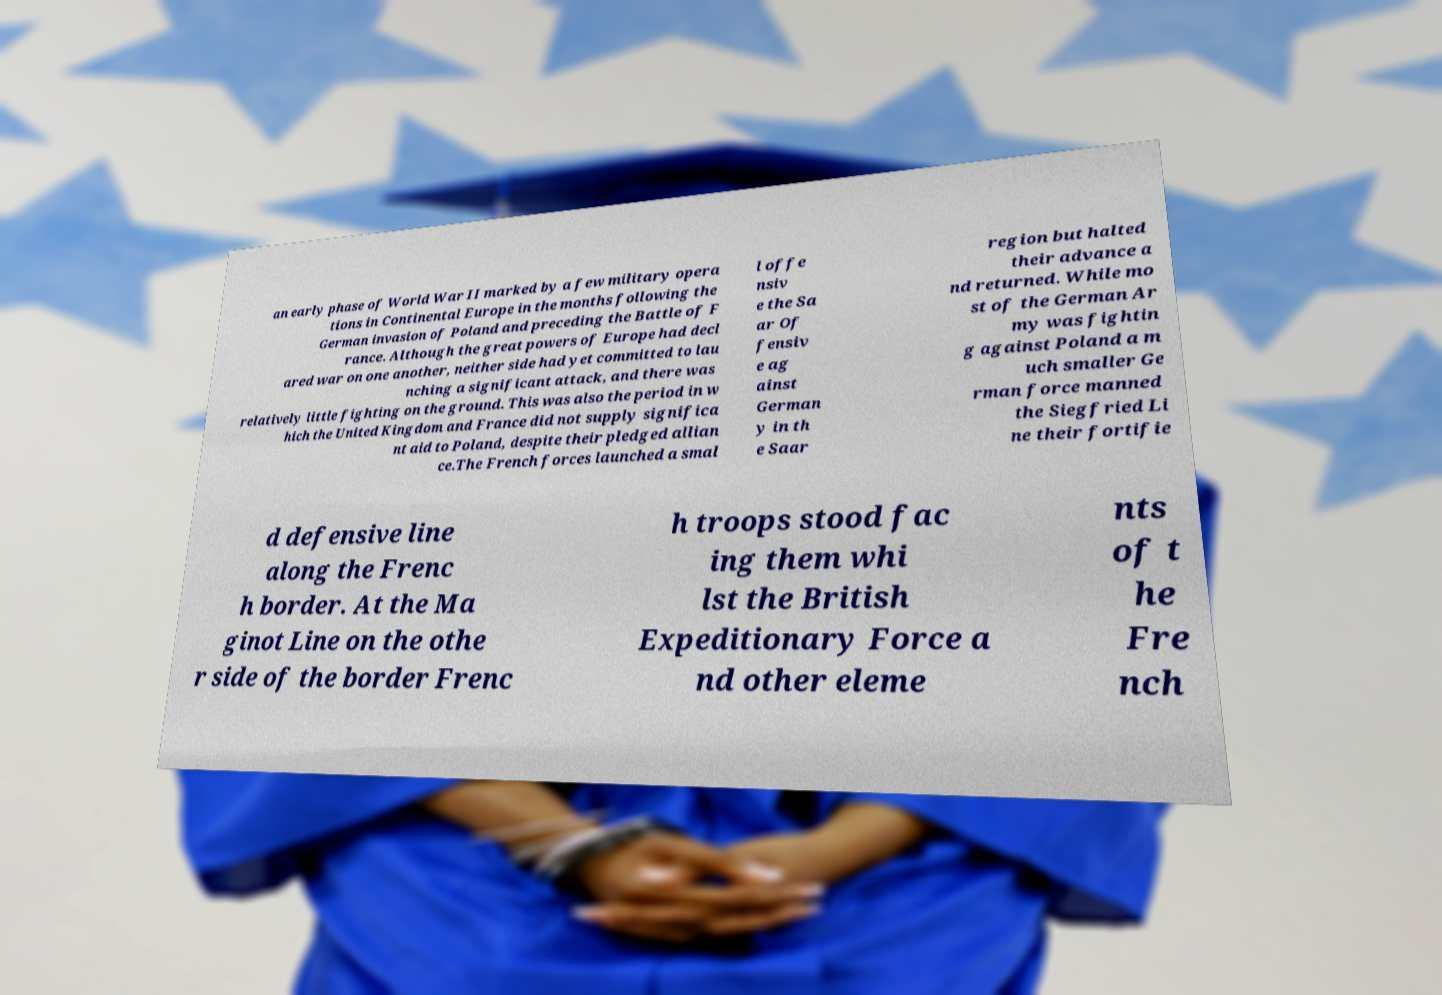There's text embedded in this image that I need extracted. Can you transcribe it verbatim? an early phase of World War II marked by a few military opera tions in Continental Europe in the months following the German invasion of Poland and preceding the Battle of F rance. Although the great powers of Europe had decl ared war on one another, neither side had yet committed to lau nching a significant attack, and there was relatively little fighting on the ground. This was also the period in w hich the United Kingdom and France did not supply significa nt aid to Poland, despite their pledged allian ce.The French forces launched a smal l offe nsiv e the Sa ar Of fensiv e ag ainst German y in th e Saar region but halted their advance a nd returned. While mo st of the German Ar my was fightin g against Poland a m uch smaller Ge rman force manned the Siegfried Li ne their fortifie d defensive line along the Frenc h border. At the Ma ginot Line on the othe r side of the border Frenc h troops stood fac ing them whi lst the British Expeditionary Force a nd other eleme nts of t he Fre nch 